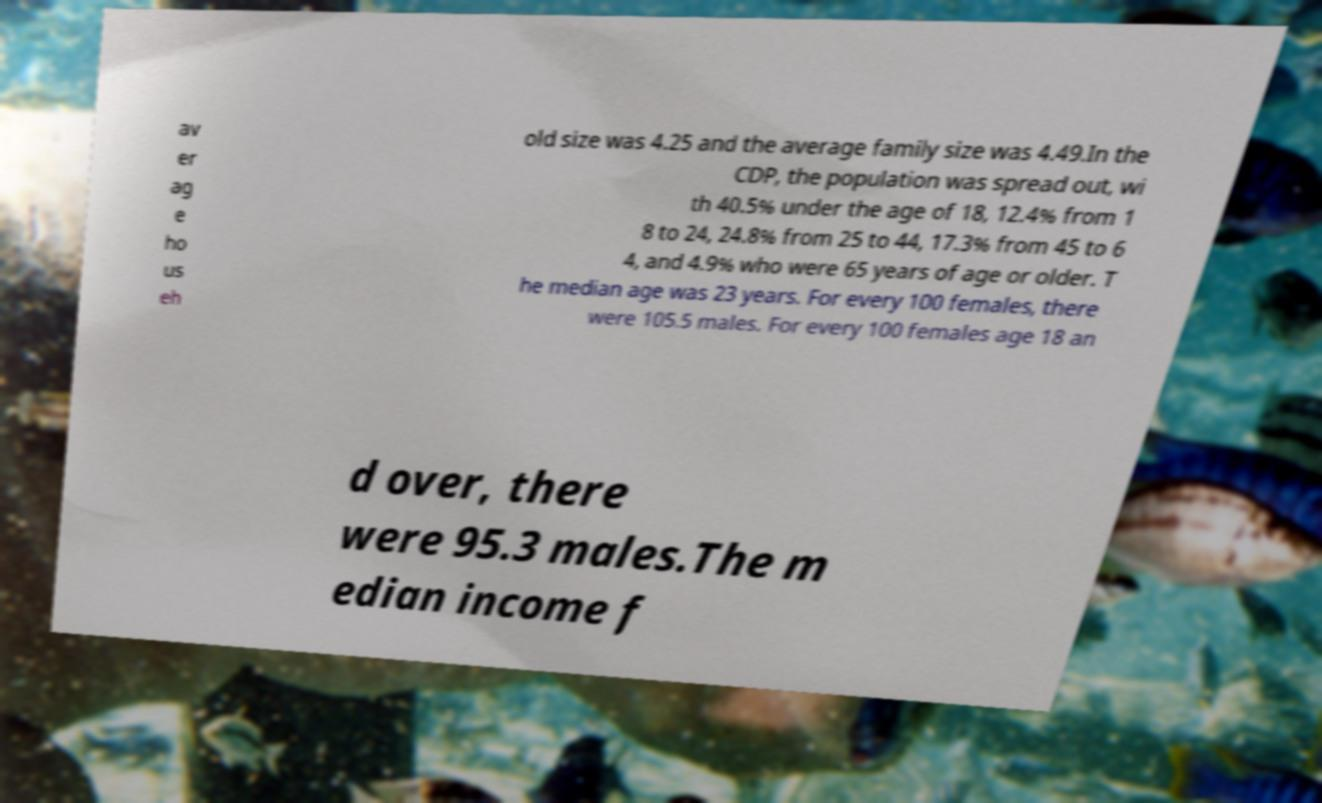What messages or text are displayed in this image? I need them in a readable, typed format. av er ag e ho us eh old size was 4.25 and the average family size was 4.49.In the CDP, the population was spread out, wi th 40.5% under the age of 18, 12.4% from 1 8 to 24, 24.8% from 25 to 44, 17.3% from 45 to 6 4, and 4.9% who were 65 years of age or older. T he median age was 23 years. For every 100 females, there were 105.5 males. For every 100 females age 18 an d over, there were 95.3 males.The m edian income f 